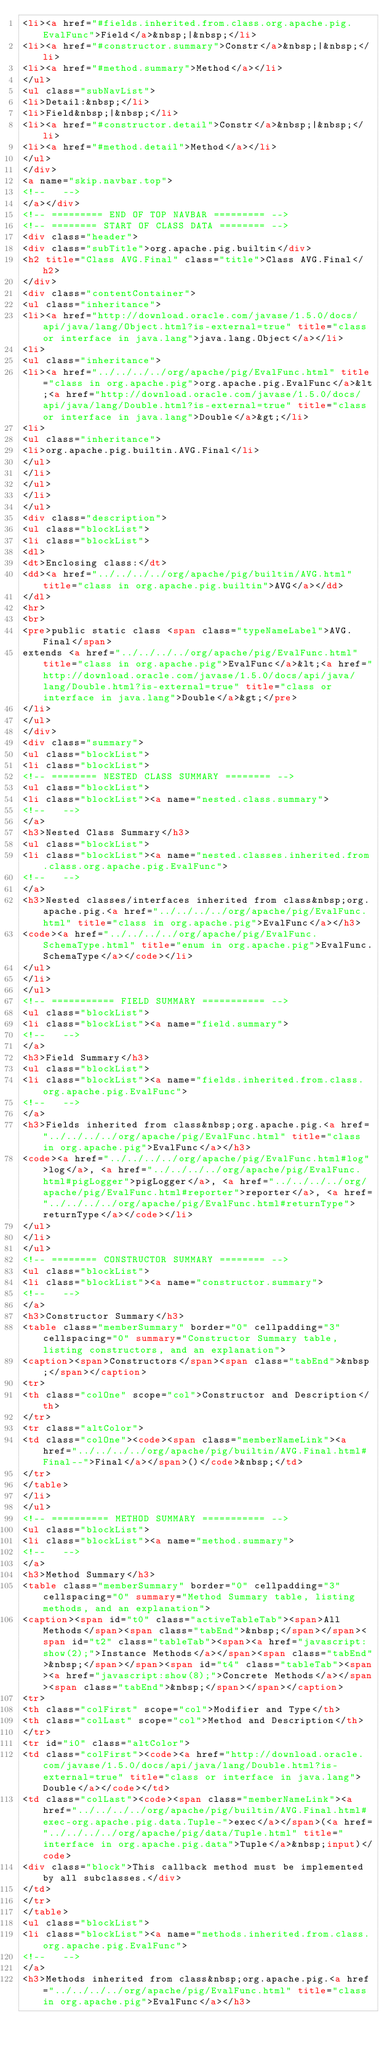<code> <loc_0><loc_0><loc_500><loc_500><_HTML_><li><a href="#fields.inherited.from.class.org.apache.pig.EvalFunc">Field</a>&nbsp;|&nbsp;</li>
<li><a href="#constructor.summary">Constr</a>&nbsp;|&nbsp;</li>
<li><a href="#method.summary">Method</a></li>
</ul>
<ul class="subNavList">
<li>Detail:&nbsp;</li>
<li>Field&nbsp;|&nbsp;</li>
<li><a href="#constructor.detail">Constr</a>&nbsp;|&nbsp;</li>
<li><a href="#method.detail">Method</a></li>
</ul>
</div>
<a name="skip.navbar.top">
<!--   -->
</a></div>
<!-- ========= END OF TOP NAVBAR ========= -->
<!-- ======== START OF CLASS DATA ======== -->
<div class="header">
<div class="subTitle">org.apache.pig.builtin</div>
<h2 title="Class AVG.Final" class="title">Class AVG.Final</h2>
</div>
<div class="contentContainer">
<ul class="inheritance">
<li><a href="http://download.oracle.com/javase/1.5.0/docs/api/java/lang/Object.html?is-external=true" title="class or interface in java.lang">java.lang.Object</a></li>
<li>
<ul class="inheritance">
<li><a href="../../../../org/apache/pig/EvalFunc.html" title="class in org.apache.pig">org.apache.pig.EvalFunc</a>&lt;<a href="http://download.oracle.com/javase/1.5.0/docs/api/java/lang/Double.html?is-external=true" title="class or interface in java.lang">Double</a>&gt;</li>
<li>
<ul class="inheritance">
<li>org.apache.pig.builtin.AVG.Final</li>
</ul>
</li>
</ul>
</li>
</ul>
<div class="description">
<ul class="blockList">
<li class="blockList">
<dl>
<dt>Enclosing class:</dt>
<dd><a href="../../../../org/apache/pig/builtin/AVG.html" title="class in org.apache.pig.builtin">AVG</a></dd>
</dl>
<hr>
<br>
<pre>public static class <span class="typeNameLabel">AVG.Final</span>
extends <a href="../../../../org/apache/pig/EvalFunc.html" title="class in org.apache.pig">EvalFunc</a>&lt;<a href="http://download.oracle.com/javase/1.5.0/docs/api/java/lang/Double.html?is-external=true" title="class or interface in java.lang">Double</a>&gt;</pre>
</li>
</ul>
</div>
<div class="summary">
<ul class="blockList">
<li class="blockList">
<!-- ======== NESTED CLASS SUMMARY ======== -->
<ul class="blockList">
<li class="blockList"><a name="nested.class.summary">
<!--   -->
</a>
<h3>Nested Class Summary</h3>
<ul class="blockList">
<li class="blockList"><a name="nested.classes.inherited.from.class.org.apache.pig.EvalFunc">
<!--   -->
</a>
<h3>Nested classes/interfaces inherited from class&nbsp;org.apache.pig.<a href="../../../../org/apache/pig/EvalFunc.html" title="class in org.apache.pig">EvalFunc</a></h3>
<code><a href="../../../../org/apache/pig/EvalFunc.SchemaType.html" title="enum in org.apache.pig">EvalFunc.SchemaType</a></code></li>
</ul>
</li>
</ul>
<!-- =========== FIELD SUMMARY =========== -->
<ul class="blockList">
<li class="blockList"><a name="field.summary">
<!--   -->
</a>
<h3>Field Summary</h3>
<ul class="blockList">
<li class="blockList"><a name="fields.inherited.from.class.org.apache.pig.EvalFunc">
<!--   -->
</a>
<h3>Fields inherited from class&nbsp;org.apache.pig.<a href="../../../../org/apache/pig/EvalFunc.html" title="class in org.apache.pig">EvalFunc</a></h3>
<code><a href="../../../../org/apache/pig/EvalFunc.html#log">log</a>, <a href="../../../../org/apache/pig/EvalFunc.html#pigLogger">pigLogger</a>, <a href="../../../../org/apache/pig/EvalFunc.html#reporter">reporter</a>, <a href="../../../../org/apache/pig/EvalFunc.html#returnType">returnType</a></code></li>
</ul>
</li>
</ul>
<!-- ======== CONSTRUCTOR SUMMARY ======== -->
<ul class="blockList">
<li class="blockList"><a name="constructor.summary">
<!--   -->
</a>
<h3>Constructor Summary</h3>
<table class="memberSummary" border="0" cellpadding="3" cellspacing="0" summary="Constructor Summary table, listing constructors, and an explanation">
<caption><span>Constructors</span><span class="tabEnd">&nbsp;</span></caption>
<tr>
<th class="colOne" scope="col">Constructor and Description</th>
</tr>
<tr class="altColor">
<td class="colOne"><code><span class="memberNameLink"><a href="../../../../org/apache/pig/builtin/AVG.Final.html#Final--">Final</a></span>()</code>&nbsp;</td>
</tr>
</table>
</li>
</ul>
<!-- ========== METHOD SUMMARY =========== -->
<ul class="blockList">
<li class="blockList"><a name="method.summary">
<!--   -->
</a>
<h3>Method Summary</h3>
<table class="memberSummary" border="0" cellpadding="3" cellspacing="0" summary="Method Summary table, listing methods, and an explanation">
<caption><span id="t0" class="activeTableTab"><span>All Methods</span><span class="tabEnd">&nbsp;</span></span><span id="t2" class="tableTab"><span><a href="javascript:show(2);">Instance Methods</a></span><span class="tabEnd">&nbsp;</span></span><span id="t4" class="tableTab"><span><a href="javascript:show(8);">Concrete Methods</a></span><span class="tabEnd">&nbsp;</span></span></caption>
<tr>
<th class="colFirst" scope="col">Modifier and Type</th>
<th class="colLast" scope="col">Method and Description</th>
</tr>
<tr id="i0" class="altColor">
<td class="colFirst"><code><a href="http://download.oracle.com/javase/1.5.0/docs/api/java/lang/Double.html?is-external=true" title="class or interface in java.lang">Double</a></code></td>
<td class="colLast"><code><span class="memberNameLink"><a href="../../../../org/apache/pig/builtin/AVG.Final.html#exec-org.apache.pig.data.Tuple-">exec</a></span>(<a href="../../../../org/apache/pig/data/Tuple.html" title="interface in org.apache.pig.data">Tuple</a>&nbsp;input)</code>
<div class="block">This callback method must be implemented by all subclasses.</div>
</td>
</tr>
</table>
<ul class="blockList">
<li class="blockList"><a name="methods.inherited.from.class.org.apache.pig.EvalFunc">
<!--   -->
</a>
<h3>Methods inherited from class&nbsp;org.apache.pig.<a href="../../../../org/apache/pig/EvalFunc.html" title="class in org.apache.pig">EvalFunc</a></h3></code> 